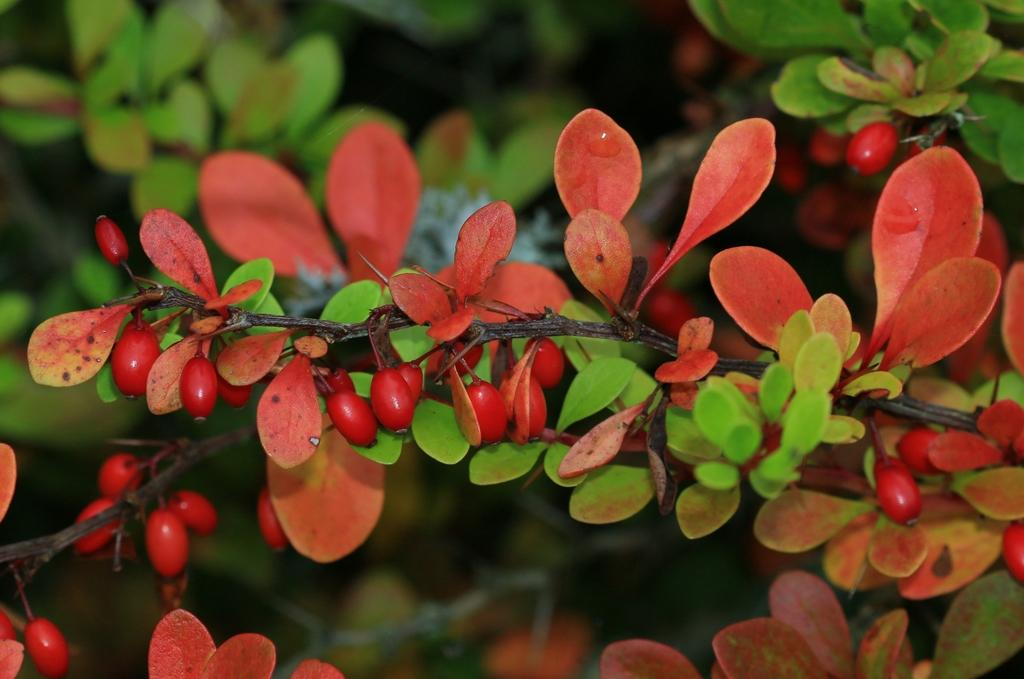What colors can be seen in the leaves in the image? There are orange and green colored leaves in the image. What color are the fruits in the image? The fruits in the image are red colored. How would you describe the overall clarity of the image? The image is slightly blurry in the background. What type of poison is being used to treat the disease in the image? There is no mention of poison or disease in the image; it features orange and green leaves and red fruits. 